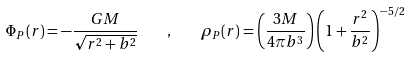<formula> <loc_0><loc_0><loc_500><loc_500>\Phi _ { P } ( r ) = - \frac { G M } { \sqrt { r ^ { 2 } + b ^ { 2 } } } \quad , \quad \rho _ { P } ( r ) = \left ( \frac { 3 M } { 4 \pi b ^ { 3 } } \right ) \left ( 1 + \frac { r ^ { 2 } } { b ^ { 2 } } \right ) ^ { - 5 / 2 }</formula> 